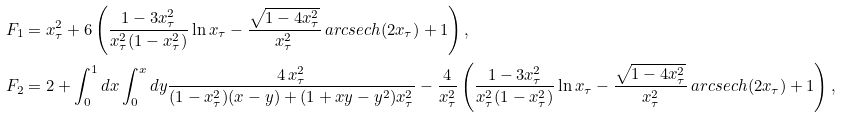<formula> <loc_0><loc_0><loc_500><loc_500>F _ { 1 } & = x ^ { 2 } _ { \tau } + 6 \left ( \frac { 1 - 3 x ^ { 2 } _ { \tau } } { x _ { \tau } ^ { 2 } ( 1 - x _ { \tau } ^ { 2 } ) } \ln x _ { \tau } - \frac { \sqrt { 1 - 4 x ^ { 2 } _ { \tau } } } { x ^ { 2 } _ { \tau } } \, a r c s e c h ( 2 x _ { \tau } ) + 1 \right ) , \\ F _ { 2 } & = 2 + \int _ { 0 } ^ { 1 } d x \int _ { 0 } ^ { x } d y \frac { 4 \, x ^ { 2 } _ { \tau } } { ( 1 - x ^ { 2 } _ { \tau } ) ( x - y ) + ( 1 + x y - y ^ { 2 } ) x ^ { 2 } _ { \tau } } - \frac { 4 } { x _ { \tau } ^ { 2 } } \left ( \frac { 1 - 3 x ^ { 2 } _ { \tau } } { x _ { \tau } ^ { 2 } ( 1 - x _ { \tau } ^ { 2 } ) } \ln x _ { \tau } - \frac { \sqrt { 1 - 4 x ^ { 2 } _ { \tau } } } { x ^ { 2 } _ { \tau } } \, a r c s e c h ( 2 x _ { \tau } ) + 1 \right ) ,</formula> 